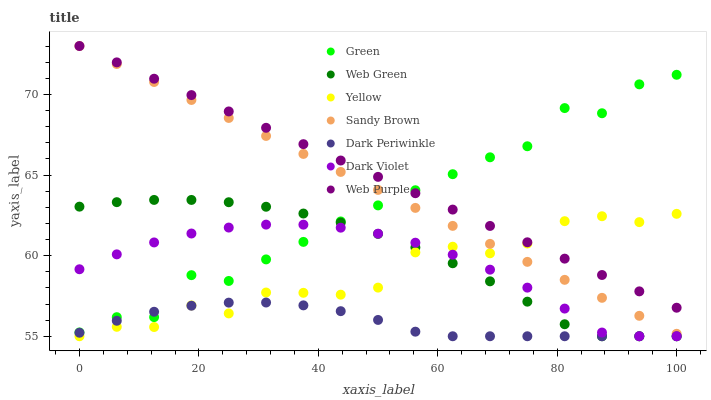Does Dark Periwinkle have the minimum area under the curve?
Answer yes or no. Yes. Does Web Purple have the maximum area under the curve?
Answer yes or no. Yes. Does Dark Violet have the minimum area under the curve?
Answer yes or no. No. Does Dark Violet have the maximum area under the curve?
Answer yes or no. No. Is Web Purple the smoothest?
Answer yes or no. Yes. Is Green the roughest?
Answer yes or no. Yes. Is Dark Violet the smoothest?
Answer yes or no. No. Is Dark Violet the roughest?
Answer yes or no. No. Does Web Green have the lowest value?
Answer yes or no. Yes. Does Web Purple have the lowest value?
Answer yes or no. No. Does Sandy Brown have the highest value?
Answer yes or no. Yes. Does Dark Violet have the highest value?
Answer yes or no. No. Is Dark Violet less than Sandy Brown?
Answer yes or no. Yes. Is Green greater than Yellow?
Answer yes or no. Yes. Does Green intersect Web Purple?
Answer yes or no. Yes. Is Green less than Web Purple?
Answer yes or no. No. Is Green greater than Web Purple?
Answer yes or no. No. Does Dark Violet intersect Sandy Brown?
Answer yes or no. No. 